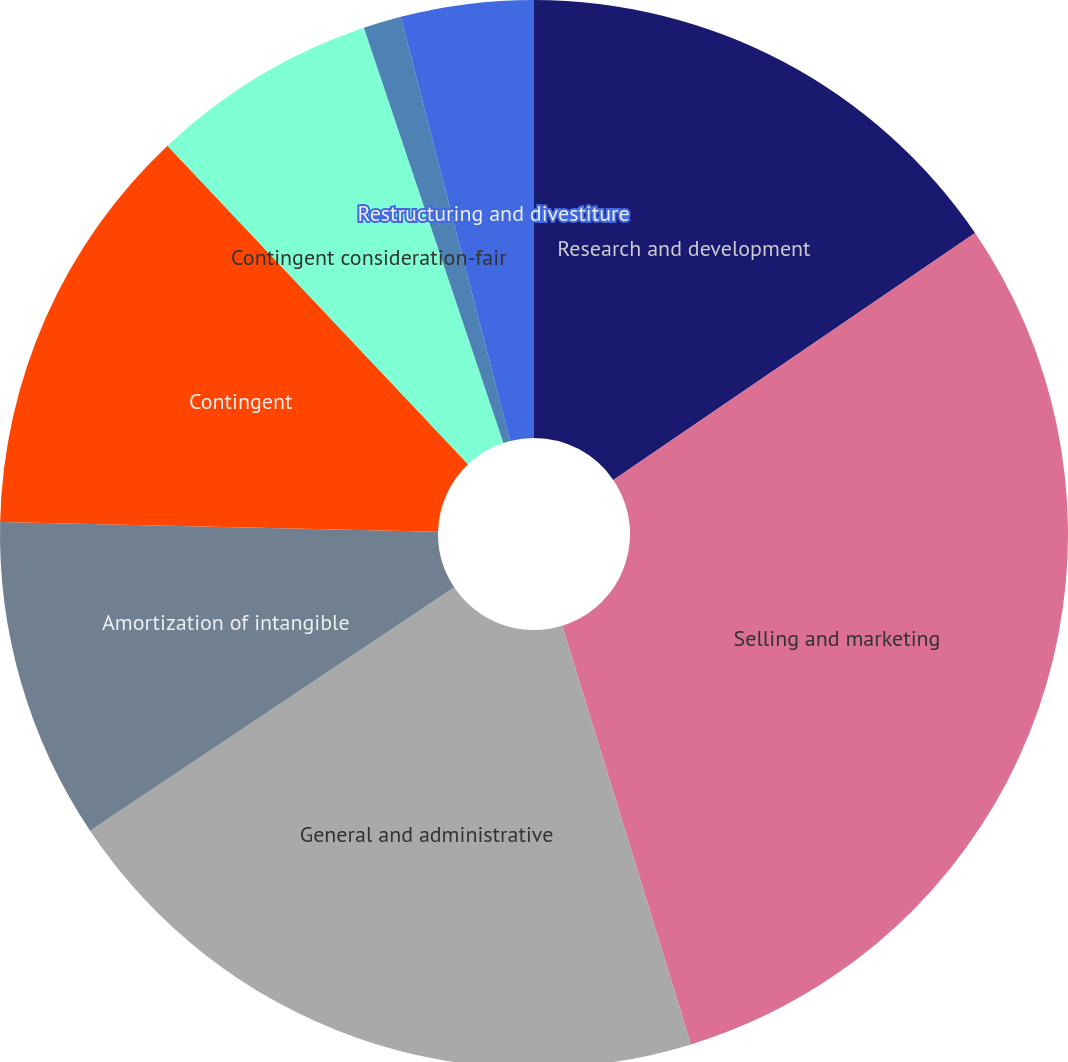Convert chart to OTSL. <chart><loc_0><loc_0><loc_500><loc_500><pie_chart><fcel>Research and development<fcel>Selling and marketing<fcel>General and administrative<fcel>Amortization of intangible<fcel>Contingent<fcel>Contingent consideration-fair<fcel>Gain on sale of intellectual<fcel>Restructuring and divestiture<nl><fcel>15.47%<fcel>29.78%<fcel>20.37%<fcel>9.74%<fcel>12.6%<fcel>6.88%<fcel>1.15%<fcel>4.01%<nl></chart> 